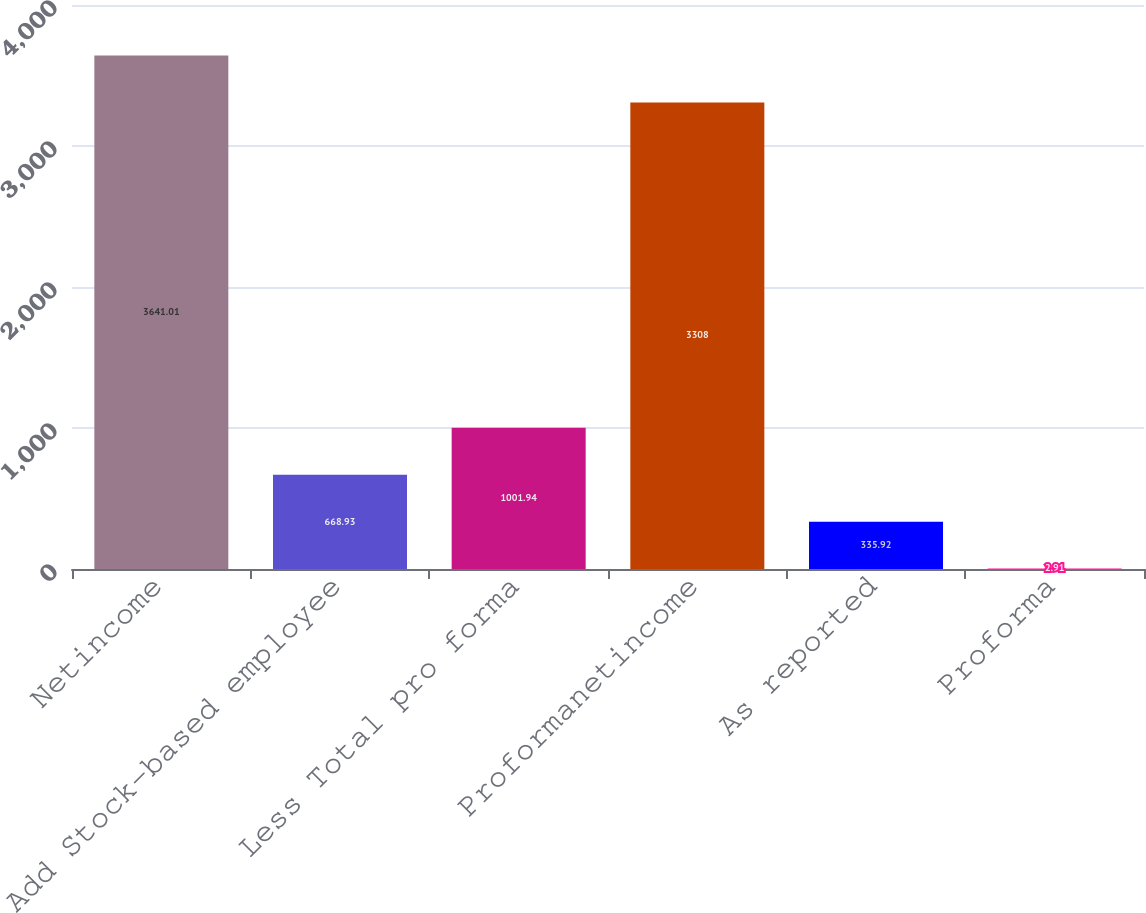Convert chart to OTSL. <chart><loc_0><loc_0><loc_500><loc_500><bar_chart><fcel>Netincome<fcel>Add Stock-based employee<fcel>Less Total pro forma<fcel>Proformanetincome<fcel>As reported<fcel>Proforma<nl><fcel>3641.01<fcel>668.93<fcel>1001.94<fcel>3308<fcel>335.92<fcel>2.91<nl></chart> 